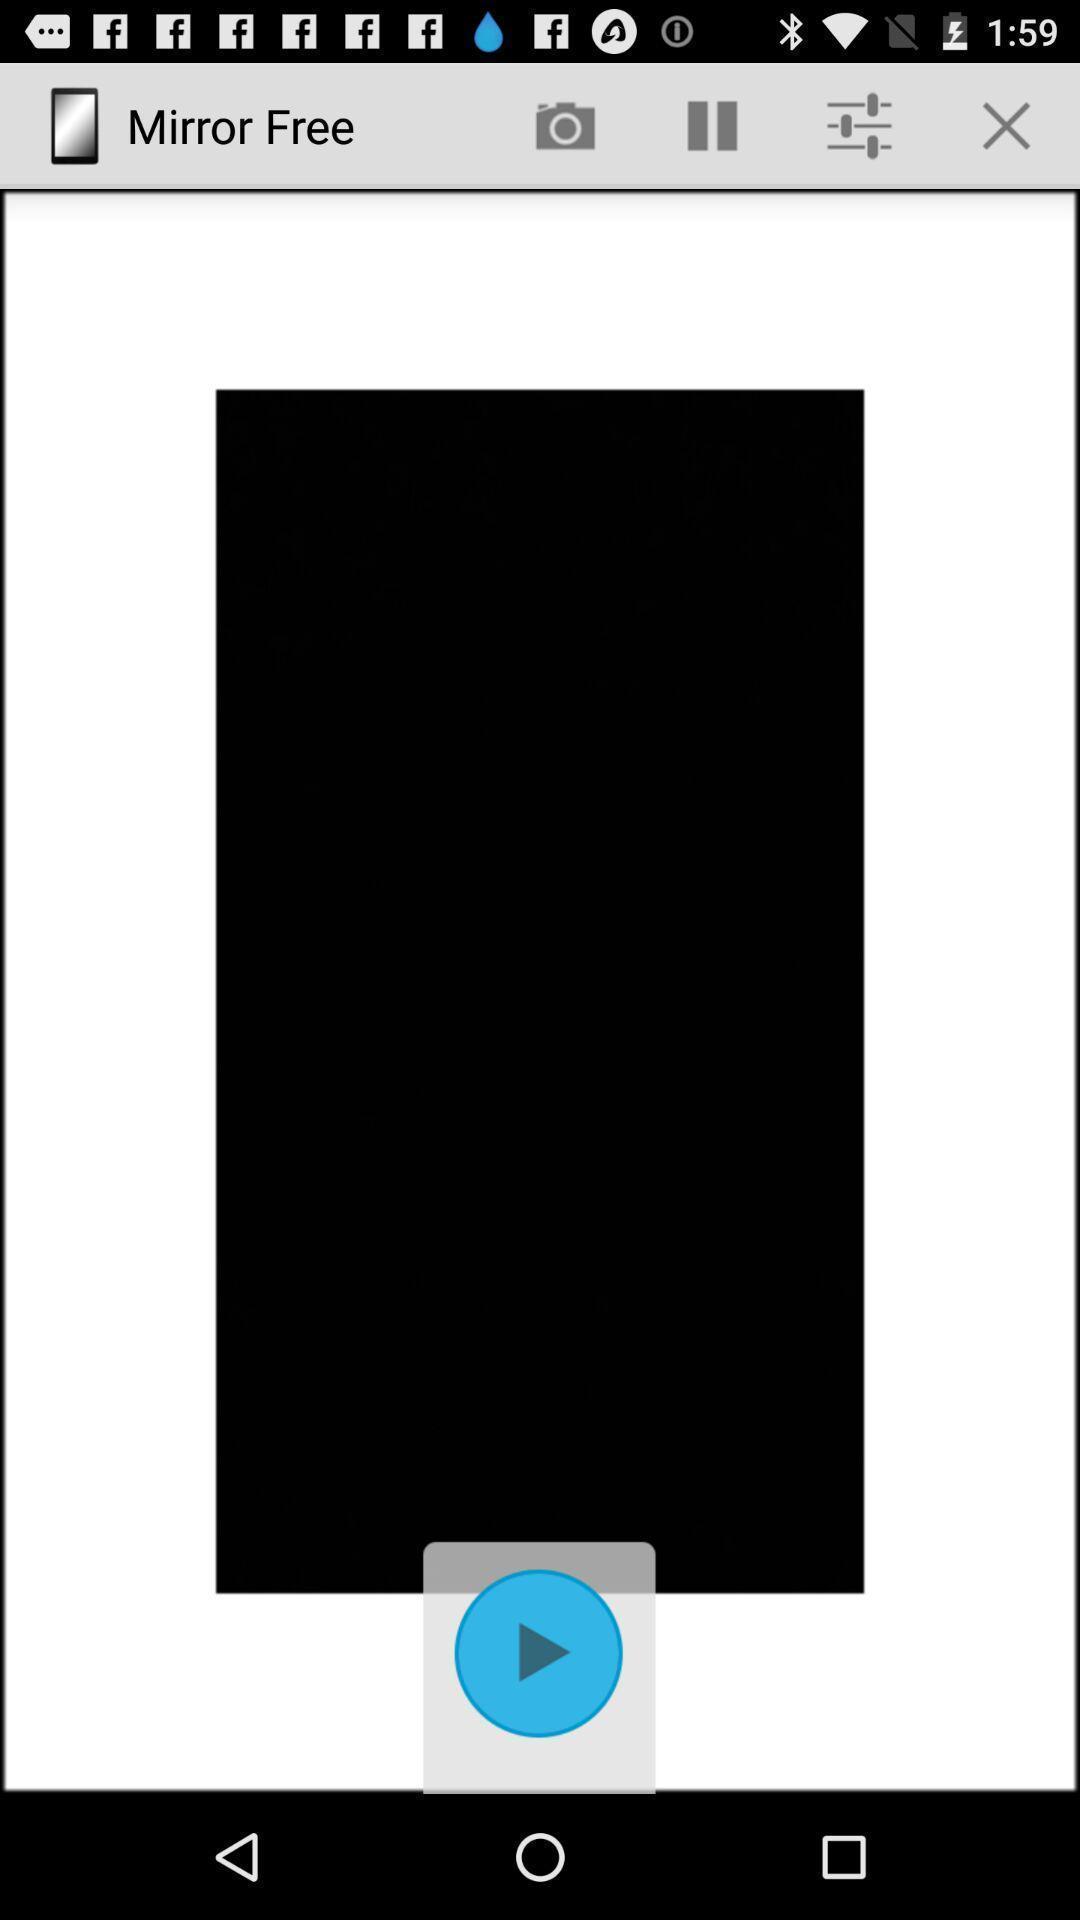Provide a description of this screenshot. Screen displaying a video with multiple controls. 